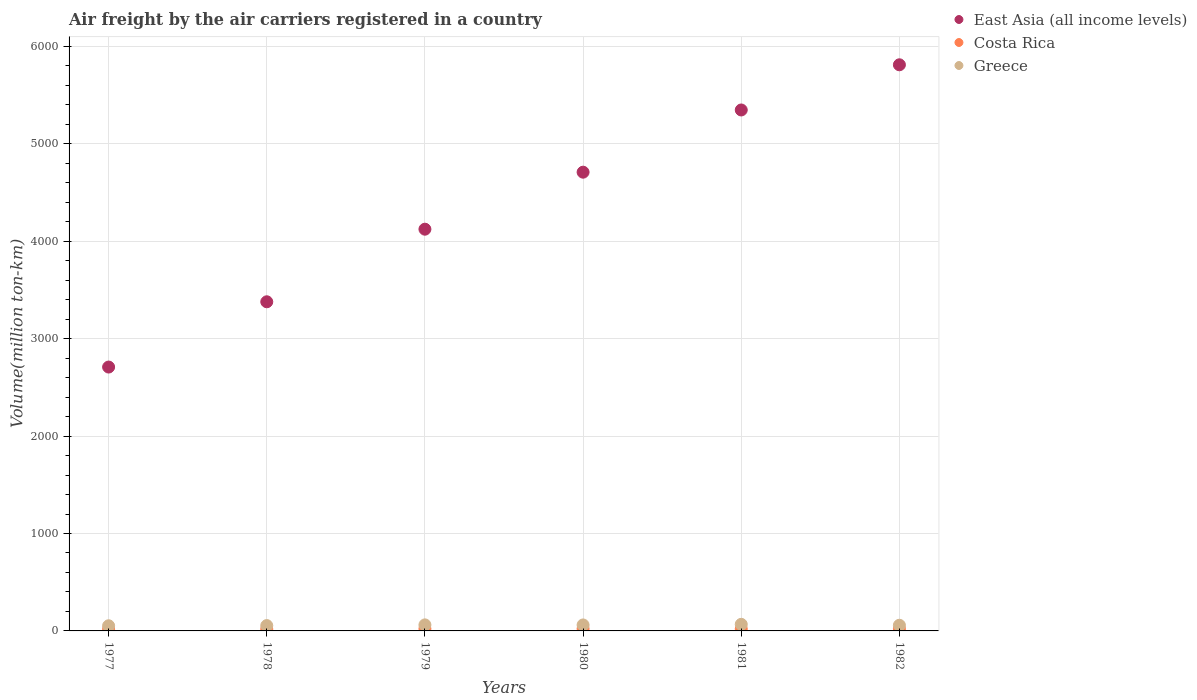What is the volume of the air carriers in East Asia (all income levels) in 1979?
Give a very brief answer. 4124.3. Across all years, what is the maximum volume of the air carriers in Greece?
Make the answer very short. 67.6. Across all years, what is the minimum volume of the air carriers in Costa Rica?
Offer a terse response. 18.3. What is the total volume of the air carriers in Greece in the graph?
Provide a succinct answer. 357.1. What is the difference between the volume of the air carriers in Greece in 1978 and that in 1981?
Your answer should be compact. -12.7. What is the difference between the volume of the air carriers in East Asia (all income levels) in 1981 and the volume of the air carriers in Greece in 1978?
Provide a succinct answer. 5293.4. What is the average volume of the air carriers in Greece per year?
Make the answer very short. 59.52. In the year 1979, what is the difference between the volume of the air carriers in Greece and volume of the air carriers in Costa Rica?
Ensure brevity in your answer.  40.1. What is the ratio of the volume of the air carriers in Greece in 1978 to that in 1980?
Provide a short and direct response. 0.89. Is the volume of the air carriers in East Asia (all income levels) in 1978 less than that in 1980?
Your response must be concise. Yes. What is the difference between the highest and the second highest volume of the air carriers in East Asia (all income levels)?
Your answer should be compact. 463.8. What is the difference between the highest and the lowest volume of the air carriers in Greece?
Provide a succinct answer. 14.7. In how many years, is the volume of the air carriers in Greece greater than the average volume of the air carriers in Greece taken over all years?
Ensure brevity in your answer.  3. Is the sum of the volume of the air carriers in Greece in 1981 and 1982 greater than the maximum volume of the air carriers in East Asia (all income levels) across all years?
Provide a short and direct response. No. Does the volume of the air carriers in Costa Rica monotonically increase over the years?
Give a very brief answer. No. Is the volume of the air carriers in East Asia (all income levels) strictly greater than the volume of the air carriers in Costa Rica over the years?
Ensure brevity in your answer.  Yes. Is the volume of the air carriers in Costa Rica strictly less than the volume of the air carriers in Greece over the years?
Offer a very short reply. Yes. How many years are there in the graph?
Offer a terse response. 6. What is the difference between two consecutive major ticks on the Y-axis?
Provide a short and direct response. 1000. Does the graph contain any zero values?
Provide a short and direct response. No. Does the graph contain grids?
Your answer should be compact. Yes. How are the legend labels stacked?
Make the answer very short. Vertical. What is the title of the graph?
Ensure brevity in your answer.  Air freight by the air carriers registered in a country. Does "Zambia" appear as one of the legend labels in the graph?
Your response must be concise. No. What is the label or title of the Y-axis?
Keep it short and to the point. Volume(million ton-km). What is the Volume(million ton-km) of East Asia (all income levels) in 1977?
Offer a very short reply. 2709. What is the Volume(million ton-km) in Costa Rica in 1977?
Provide a short and direct response. 18.3. What is the Volume(million ton-km) in Greece in 1977?
Keep it short and to the point. 52.9. What is the Volume(million ton-km) of East Asia (all income levels) in 1978?
Your answer should be compact. 3379.1. What is the Volume(million ton-km) of Costa Rica in 1978?
Your response must be concise. 18.9. What is the Volume(million ton-km) of Greece in 1978?
Give a very brief answer. 54.9. What is the Volume(million ton-km) in East Asia (all income levels) in 1979?
Offer a very short reply. 4124.3. What is the Volume(million ton-km) of Costa Rica in 1979?
Keep it short and to the point. 22. What is the Volume(million ton-km) of Greece in 1979?
Your answer should be very brief. 62.1. What is the Volume(million ton-km) in East Asia (all income levels) in 1980?
Ensure brevity in your answer.  4709.6. What is the Volume(million ton-km) in Costa Rica in 1980?
Your answer should be compact. 22.4. What is the Volume(million ton-km) in Greece in 1980?
Make the answer very short. 61.4. What is the Volume(million ton-km) of East Asia (all income levels) in 1981?
Give a very brief answer. 5348.3. What is the Volume(million ton-km) of Costa Rica in 1981?
Provide a short and direct response. 20.9. What is the Volume(million ton-km) of Greece in 1981?
Make the answer very short. 67.6. What is the Volume(million ton-km) of East Asia (all income levels) in 1982?
Ensure brevity in your answer.  5812.1. What is the Volume(million ton-km) of Costa Rica in 1982?
Your answer should be compact. 21.5. What is the Volume(million ton-km) of Greece in 1982?
Ensure brevity in your answer.  58.2. Across all years, what is the maximum Volume(million ton-km) of East Asia (all income levels)?
Your answer should be compact. 5812.1. Across all years, what is the maximum Volume(million ton-km) of Costa Rica?
Provide a succinct answer. 22.4. Across all years, what is the maximum Volume(million ton-km) of Greece?
Make the answer very short. 67.6. Across all years, what is the minimum Volume(million ton-km) in East Asia (all income levels)?
Provide a succinct answer. 2709. Across all years, what is the minimum Volume(million ton-km) of Costa Rica?
Offer a terse response. 18.3. Across all years, what is the minimum Volume(million ton-km) of Greece?
Your response must be concise. 52.9. What is the total Volume(million ton-km) of East Asia (all income levels) in the graph?
Keep it short and to the point. 2.61e+04. What is the total Volume(million ton-km) of Costa Rica in the graph?
Offer a very short reply. 124. What is the total Volume(million ton-km) of Greece in the graph?
Ensure brevity in your answer.  357.1. What is the difference between the Volume(million ton-km) of East Asia (all income levels) in 1977 and that in 1978?
Provide a short and direct response. -670.1. What is the difference between the Volume(million ton-km) of East Asia (all income levels) in 1977 and that in 1979?
Make the answer very short. -1415.3. What is the difference between the Volume(million ton-km) in East Asia (all income levels) in 1977 and that in 1980?
Make the answer very short. -2000.6. What is the difference between the Volume(million ton-km) of East Asia (all income levels) in 1977 and that in 1981?
Offer a terse response. -2639.3. What is the difference between the Volume(million ton-km) of Costa Rica in 1977 and that in 1981?
Your answer should be compact. -2.6. What is the difference between the Volume(million ton-km) in Greece in 1977 and that in 1981?
Your response must be concise. -14.7. What is the difference between the Volume(million ton-km) of East Asia (all income levels) in 1977 and that in 1982?
Keep it short and to the point. -3103.1. What is the difference between the Volume(million ton-km) in Costa Rica in 1977 and that in 1982?
Provide a short and direct response. -3.2. What is the difference between the Volume(million ton-km) in East Asia (all income levels) in 1978 and that in 1979?
Provide a short and direct response. -745.2. What is the difference between the Volume(million ton-km) of Greece in 1978 and that in 1979?
Your answer should be very brief. -7.2. What is the difference between the Volume(million ton-km) in East Asia (all income levels) in 1978 and that in 1980?
Offer a terse response. -1330.5. What is the difference between the Volume(million ton-km) of East Asia (all income levels) in 1978 and that in 1981?
Offer a very short reply. -1969.2. What is the difference between the Volume(million ton-km) in East Asia (all income levels) in 1978 and that in 1982?
Your answer should be very brief. -2433. What is the difference between the Volume(million ton-km) of Costa Rica in 1978 and that in 1982?
Provide a short and direct response. -2.6. What is the difference between the Volume(million ton-km) of Greece in 1978 and that in 1982?
Ensure brevity in your answer.  -3.3. What is the difference between the Volume(million ton-km) of East Asia (all income levels) in 1979 and that in 1980?
Your answer should be compact. -585.3. What is the difference between the Volume(million ton-km) in Greece in 1979 and that in 1980?
Offer a terse response. 0.7. What is the difference between the Volume(million ton-km) in East Asia (all income levels) in 1979 and that in 1981?
Give a very brief answer. -1224. What is the difference between the Volume(million ton-km) in Costa Rica in 1979 and that in 1981?
Keep it short and to the point. 1.1. What is the difference between the Volume(million ton-km) in Greece in 1979 and that in 1981?
Keep it short and to the point. -5.5. What is the difference between the Volume(million ton-km) in East Asia (all income levels) in 1979 and that in 1982?
Provide a succinct answer. -1687.8. What is the difference between the Volume(million ton-km) in Greece in 1979 and that in 1982?
Keep it short and to the point. 3.9. What is the difference between the Volume(million ton-km) of East Asia (all income levels) in 1980 and that in 1981?
Give a very brief answer. -638.7. What is the difference between the Volume(million ton-km) of Costa Rica in 1980 and that in 1981?
Make the answer very short. 1.5. What is the difference between the Volume(million ton-km) of Greece in 1980 and that in 1981?
Give a very brief answer. -6.2. What is the difference between the Volume(million ton-km) of East Asia (all income levels) in 1980 and that in 1982?
Your answer should be compact. -1102.5. What is the difference between the Volume(million ton-km) of Costa Rica in 1980 and that in 1982?
Keep it short and to the point. 0.9. What is the difference between the Volume(million ton-km) in East Asia (all income levels) in 1981 and that in 1982?
Ensure brevity in your answer.  -463.8. What is the difference between the Volume(million ton-km) in Greece in 1981 and that in 1982?
Keep it short and to the point. 9.4. What is the difference between the Volume(million ton-km) of East Asia (all income levels) in 1977 and the Volume(million ton-km) of Costa Rica in 1978?
Your response must be concise. 2690.1. What is the difference between the Volume(million ton-km) of East Asia (all income levels) in 1977 and the Volume(million ton-km) of Greece in 1978?
Offer a very short reply. 2654.1. What is the difference between the Volume(million ton-km) of Costa Rica in 1977 and the Volume(million ton-km) of Greece in 1978?
Give a very brief answer. -36.6. What is the difference between the Volume(million ton-km) of East Asia (all income levels) in 1977 and the Volume(million ton-km) of Costa Rica in 1979?
Provide a short and direct response. 2687. What is the difference between the Volume(million ton-km) in East Asia (all income levels) in 1977 and the Volume(million ton-km) in Greece in 1979?
Offer a very short reply. 2646.9. What is the difference between the Volume(million ton-km) in Costa Rica in 1977 and the Volume(million ton-km) in Greece in 1979?
Ensure brevity in your answer.  -43.8. What is the difference between the Volume(million ton-km) of East Asia (all income levels) in 1977 and the Volume(million ton-km) of Costa Rica in 1980?
Your answer should be compact. 2686.6. What is the difference between the Volume(million ton-km) of East Asia (all income levels) in 1977 and the Volume(million ton-km) of Greece in 1980?
Give a very brief answer. 2647.6. What is the difference between the Volume(million ton-km) in Costa Rica in 1977 and the Volume(million ton-km) in Greece in 1980?
Give a very brief answer. -43.1. What is the difference between the Volume(million ton-km) of East Asia (all income levels) in 1977 and the Volume(million ton-km) of Costa Rica in 1981?
Keep it short and to the point. 2688.1. What is the difference between the Volume(million ton-km) in East Asia (all income levels) in 1977 and the Volume(million ton-km) in Greece in 1981?
Ensure brevity in your answer.  2641.4. What is the difference between the Volume(million ton-km) of Costa Rica in 1977 and the Volume(million ton-km) of Greece in 1981?
Offer a very short reply. -49.3. What is the difference between the Volume(million ton-km) in East Asia (all income levels) in 1977 and the Volume(million ton-km) in Costa Rica in 1982?
Your answer should be very brief. 2687.5. What is the difference between the Volume(million ton-km) of East Asia (all income levels) in 1977 and the Volume(million ton-km) of Greece in 1982?
Provide a short and direct response. 2650.8. What is the difference between the Volume(million ton-km) of Costa Rica in 1977 and the Volume(million ton-km) of Greece in 1982?
Offer a very short reply. -39.9. What is the difference between the Volume(million ton-km) in East Asia (all income levels) in 1978 and the Volume(million ton-km) in Costa Rica in 1979?
Your response must be concise. 3357.1. What is the difference between the Volume(million ton-km) of East Asia (all income levels) in 1978 and the Volume(million ton-km) of Greece in 1979?
Ensure brevity in your answer.  3317. What is the difference between the Volume(million ton-km) of Costa Rica in 1978 and the Volume(million ton-km) of Greece in 1979?
Keep it short and to the point. -43.2. What is the difference between the Volume(million ton-km) of East Asia (all income levels) in 1978 and the Volume(million ton-km) of Costa Rica in 1980?
Make the answer very short. 3356.7. What is the difference between the Volume(million ton-km) in East Asia (all income levels) in 1978 and the Volume(million ton-km) in Greece in 1980?
Offer a very short reply. 3317.7. What is the difference between the Volume(million ton-km) of Costa Rica in 1978 and the Volume(million ton-km) of Greece in 1980?
Ensure brevity in your answer.  -42.5. What is the difference between the Volume(million ton-km) in East Asia (all income levels) in 1978 and the Volume(million ton-km) in Costa Rica in 1981?
Offer a terse response. 3358.2. What is the difference between the Volume(million ton-km) of East Asia (all income levels) in 1978 and the Volume(million ton-km) of Greece in 1981?
Keep it short and to the point. 3311.5. What is the difference between the Volume(million ton-km) in Costa Rica in 1978 and the Volume(million ton-km) in Greece in 1981?
Ensure brevity in your answer.  -48.7. What is the difference between the Volume(million ton-km) in East Asia (all income levels) in 1978 and the Volume(million ton-km) in Costa Rica in 1982?
Your answer should be very brief. 3357.6. What is the difference between the Volume(million ton-km) of East Asia (all income levels) in 1978 and the Volume(million ton-km) of Greece in 1982?
Give a very brief answer. 3320.9. What is the difference between the Volume(million ton-km) in Costa Rica in 1978 and the Volume(million ton-km) in Greece in 1982?
Your response must be concise. -39.3. What is the difference between the Volume(million ton-km) of East Asia (all income levels) in 1979 and the Volume(million ton-km) of Costa Rica in 1980?
Your answer should be very brief. 4101.9. What is the difference between the Volume(million ton-km) in East Asia (all income levels) in 1979 and the Volume(million ton-km) in Greece in 1980?
Provide a short and direct response. 4062.9. What is the difference between the Volume(million ton-km) of Costa Rica in 1979 and the Volume(million ton-km) of Greece in 1980?
Keep it short and to the point. -39.4. What is the difference between the Volume(million ton-km) of East Asia (all income levels) in 1979 and the Volume(million ton-km) of Costa Rica in 1981?
Your answer should be very brief. 4103.4. What is the difference between the Volume(million ton-km) in East Asia (all income levels) in 1979 and the Volume(million ton-km) in Greece in 1981?
Keep it short and to the point. 4056.7. What is the difference between the Volume(million ton-km) in Costa Rica in 1979 and the Volume(million ton-km) in Greece in 1981?
Offer a terse response. -45.6. What is the difference between the Volume(million ton-km) of East Asia (all income levels) in 1979 and the Volume(million ton-km) of Costa Rica in 1982?
Ensure brevity in your answer.  4102.8. What is the difference between the Volume(million ton-km) of East Asia (all income levels) in 1979 and the Volume(million ton-km) of Greece in 1982?
Offer a very short reply. 4066.1. What is the difference between the Volume(million ton-km) in Costa Rica in 1979 and the Volume(million ton-km) in Greece in 1982?
Keep it short and to the point. -36.2. What is the difference between the Volume(million ton-km) of East Asia (all income levels) in 1980 and the Volume(million ton-km) of Costa Rica in 1981?
Your response must be concise. 4688.7. What is the difference between the Volume(million ton-km) of East Asia (all income levels) in 1980 and the Volume(million ton-km) of Greece in 1981?
Make the answer very short. 4642. What is the difference between the Volume(million ton-km) of Costa Rica in 1980 and the Volume(million ton-km) of Greece in 1981?
Offer a terse response. -45.2. What is the difference between the Volume(million ton-km) in East Asia (all income levels) in 1980 and the Volume(million ton-km) in Costa Rica in 1982?
Ensure brevity in your answer.  4688.1. What is the difference between the Volume(million ton-km) in East Asia (all income levels) in 1980 and the Volume(million ton-km) in Greece in 1982?
Your answer should be compact. 4651.4. What is the difference between the Volume(million ton-km) in Costa Rica in 1980 and the Volume(million ton-km) in Greece in 1982?
Your response must be concise. -35.8. What is the difference between the Volume(million ton-km) of East Asia (all income levels) in 1981 and the Volume(million ton-km) of Costa Rica in 1982?
Provide a succinct answer. 5326.8. What is the difference between the Volume(million ton-km) of East Asia (all income levels) in 1981 and the Volume(million ton-km) of Greece in 1982?
Your response must be concise. 5290.1. What is the difference between the Volume(million ton-km) in Costa Rica in 1981 and the Volume(million ton-km) in Greece in 1982?
Provide a succinct answer. -37.3. What is the average Volume(million ton-km) of East Asia (all income levels) per year?
Make the answer very short. 4347.07. What is the average Volume(million ton-km) of Costa Rica per year?
Ensure brevity in your answer.  20.67. What is the average Volume(million ton-km) of Greece per year?
Provide a short and direct response. 59.52. In the year 1977, what is the difference between the Volume(million ton-km) in East Asia (all income levels) and Volume(million ton-km) in Costa Rica?
Give a very brief answer. 2690.7. In the year 1977, what is the difference between the Volume(million ton-km) of East Asia (all income levels) and Volume(million ton-km) of Greece?
Keep it short and to the point. 2656.1. In the year 1977, what is the difference between the Volume(million ton-km) of Costa Rica and Volume(million ton-km) of Greece?
Make the answer very short. -34.6. In the year 1978, what is the difference between the Volume(million ton-km) in East Asia (all income levels) and Volume(million ton-km) in Costa Rica?
Ensure brevity in your answer.  3360.2. In the year 1978, what is the difference between the Volume(million ton-km) in East Asia (all income levels) and Volume(million ton-km) in Greece?
Give a very brief answer. 3324.2. In the year 1978, what is the difference between the Volume(million ton-km) of Costa Rica and Volume(million ton-km) of Greece?
Offer a terse response. -36. In the year 1979, what is the difference between the Volume(million ton-km) of East Asia (all income levels) and Volume(million ton-km) of Costa Rica?
Provide a short and direct response. 4102.3. In the year 1979, what is the difference between the Volume(million ton-km) in East Asia (all income levels) and Volume(million ton-km) in Greece?
Your response must be concise. 4062.2. In the year 1979, what is the difference between the Volume(million ton-km) of Costa Rica and Volume(million ton-km) of Greece?
Your answer should be very brief. -40.1. In the year 1980, what is the difference between the Volume(million ton-km) of East Asia (all income levels) and Volume(million ton-km) of Costa Rica?
Give a very brief answer. 4687.2. In the year 1980, what is the difference between the Volume(million ton-km) of East Asia (all income levels) and Volume(million ton-km) of Greece?
Your answer should be very brief. 4648.2. In the year 1980, what is the difference between the Volume(million ton-km) of Costa Rica and Volume(million ton-km) of Greece?
Ensure brevity in your answer.  -39. In the year 1981, what is the difference between the Volume(million ton-km) in East Asia (all income levels) and Volume(million ton-km) in Costa Rica?
Give a very brief answer. 5327.4. In the year 1981, what is the difference between the Volume(million ton-km) in East Asia (all income levels) and Volume(million ton-km) in Greece?
Ensure brevity in your answer.  5280.7. In the year 1981, what is the difference between the Volume(million ton-km) in Costa Rica and Volume(million ton-km) in Greece?
Your response must be concise. -46.7. In the year 1982, what is the difference between the Volume(million ton-km) in East Asia (all income levels) and Volume(million ton-km) in Costa Rica?
Provide a succinct answer. 5790.6. In the year 1982, what is the difference between the Volume(million ton-km) of East Asia (all income levels) and Volume(million ton-km) of Greece?
Your response must be concise. 5753.9. In the year 1982, what is the difference between the Volume(million ton-km) of Costa Rica and Volume(million ton-km) of Greece?
Offer a very short reply. -36.7. What is the ratio of the Volume(million ton-km) in East Asia (all income levels) in 1977 to that in 1978?
Provide a succinct answer. 0.8. What is the ratio of the Volume(million ton-km) in Costa Rica in 1977 to that in 1978?
Offer a terse response. 0.97. What is the ratio of the Volume(million ton-km) of Greece in 1977 to that in 1978?
Your response must be concise. 0.96. What is the ratio of the Volume(million ton-km) of East Asia (all income levels) in 1977 to that in 1979?
Provide a short and direct response. 0.66. What is the ratio of the Volume(million ton-km) of Costa Rica in 1977 to that in 1979?
Provide a short and direct response. 0.83. What is the ratio of the Volume(million ton-km) of Greece in 1977 to that in 1979?
Offer a terse response. 0.85. What is the ratio of the Volume(million ton-km) of East Asia (all income levels) in 1977 to that in 1980?
Your response must be concise. 0.58. What is the ratio of the Volume(million ton-km) of Costa Rica in 1977 to that in 1980?
Make the answer very short. 0.82. What is the ratio of the Volume(million ton-km) in Greece in 1977 to that in 1980?
Offer a terse response. 0.86. What is the ratio of the Volume(million ton-km) of East Asia (all income levels) in 1977 to that in 1981?
Your response must be concise. 0.51. What is the ratio of the Volume(million ton-km) of Costa Rica in 1977 to that in 1981?
Offer a very short reply. 0.88. What is the ratio of the Volume(million ton-km) of Greece in 1977 to that in 1981?
Provide a succinct answer. 0.78. What is the ratio of the Volume(million ton-km) of East Asia (all income levels) in 1977 to that in 1982?
Ensure brevity in your answer.  0.47. What is the ratio of the Volume(million ton-km) of Costa Rica in 1977 to that in 1982?
Ensure brevity in your answer.  0.85. What is the ratio of the Volume(million ton-km) in Greece in 1977 to that in 1982?
Provide a short and direct response. 0.91. What is the ratio of the Volume(million ton-km) in East Asia (all income levels) in 1978 to that in 1979?
Provide a succinct answer. 0.82. What is the ratio of the Volume(million ton-km) in Costa Rica in 1978 to that in 1979?
Give a very brief answer. 0.86. What is the ratio of the Volume(million ton-km) in Greece in 1978 to that in 1979?
Keep it short and to the point. 0.88. What is the ratio of the Volume(million ton-km) of East Asia (all income levels) in 1978 to that in 1980?
Your answer should be very brief. 0.72. What is the ratio of the Volume(million ton-km) in Costa Rica in 1978 to that in 1980?
Keep it short and to the point. 0.84. What is the ratio of the Volume(million ton-km) in Greece in 1978 to that in 1980?
Your answer should be very brief. 0.89. What is the ratio of the Volume(million ton-km) of East Asia (all income levels) in 1978 to that in 1981?
Provide a short and direct response. 0.63. What is the ratio of the Volume(million ton-km) in Costa Rica in 1978 to that in 1981?
Your response must be concise. 0.9. What is the ratio of the Volume(million ton-km) of Greece in 1978 to that in 1981?
Your answer should be very brief. 0.81. What is the ratio of the Volume(million ton-km) of East Asia (all income levels) in 1978 to that in 1982?
Ensure brevity in your answer.  0.58. What is the ratio of the Volume(million ton-km) of Costa Rica in 1978 to that in 1982?
Offer a very short reply. 0.88. What is the ratio of the Volume(million ton-km) in Greece in 1978 to that in 1982?
Your answer should be compact. 0.94. What is the ratio of the Volume(million ton-km) in East Asia (all income levels) in 1979 to that in 1980?
Give a very brief answer. 0.88. What is the ratio of the Volume(million ton-km) of Costa Rica in 1979 to that in 1980?
Ensure brevity in your answer.  0.98. What is the ratio of the Volume(million ton-km) of Greece in 1979 to that in 1980?
Make the answer very short. 1.01. What is the ratio of the Volume(million ton-km) in East Asia (all income levels) in 1979 to that in 1981?
Offer a terse response. 0.77. What is the ratio of the Volume(million ton-km) in Costa Rica in 1979 to that in 1981?
Give a very brief answer. 1.05. What is the ratio of the Volume(million ton-km) of Greece in 1979 to that in 1981?
Give a very brief answer. 0.92. What is the ratio of the Volume(million ton-km) of East Asia (all income levels) in 1979 to that in 1982?
Keep it short and to the point. 0.71. What is the ratio of the Volume(million ton-km) of Costa Rica in 1979 to that in 1982?
Give a very brief answer. 1.02. What is the ratio of the Volume(million ton-km) of Greece in 1979 to that in 1982?
Offer a very short reply. 1.07. What is the ratio of the Volume(million ton-km) of East Asia (all income levels) in 1980 to that in 1981?
Your answer should be very brief. 0.88. What is the ratio of the Volume(million ton-km) of Costa Rica in 1980 to that in 1981?
Give a very brief answer. 1.07. What is the ratio of the Volume(million ton-km) of Greece in 1980 to that in 1981?
Offer a terse response. 0.91. What is the ratio of the Volume(million ton-km) in East Asia (all income levels) in 1980 to that in 1982?
Offer a very short reply. 0.81. What is the ratio of the Volume(million ton-km) in Costa Rica in 1980 to that in 1982?
Offer a very short reply. 1.04. What is the ratio of the Volume(million ton-km) of Greece in 1980 to that in 1982?
Offer a very short reply. 1.05. What is the ratio of the Volume(million ton-km) of East Asia (all income levels) in 1981 to that in 1982?
Provide a short and direct response. 0.92. What is the ratio of the Volume(million ton-km) of Costa Rica in 1981 to that in 1982?
Offer a terse response. 0.97. What is the ratio of the Volume(million ton-km) in Greece in 1981 to that in 1982?
Keep it short and to the point. 1.16. What is the difference between the highest and the second highest Volume(million ton-km) of East Asia (all income levels)?
Provide a short and direct response. 463.8. What is the difference between the highest and the lowest Volume(million ton-km) in East Asia (all income levels)?
Ensure brevity in your answer.  3103.1. What is the difference between the highest and the lowest Volume(million ton-km) in Greece?
Offer a terse response. 14.7. 